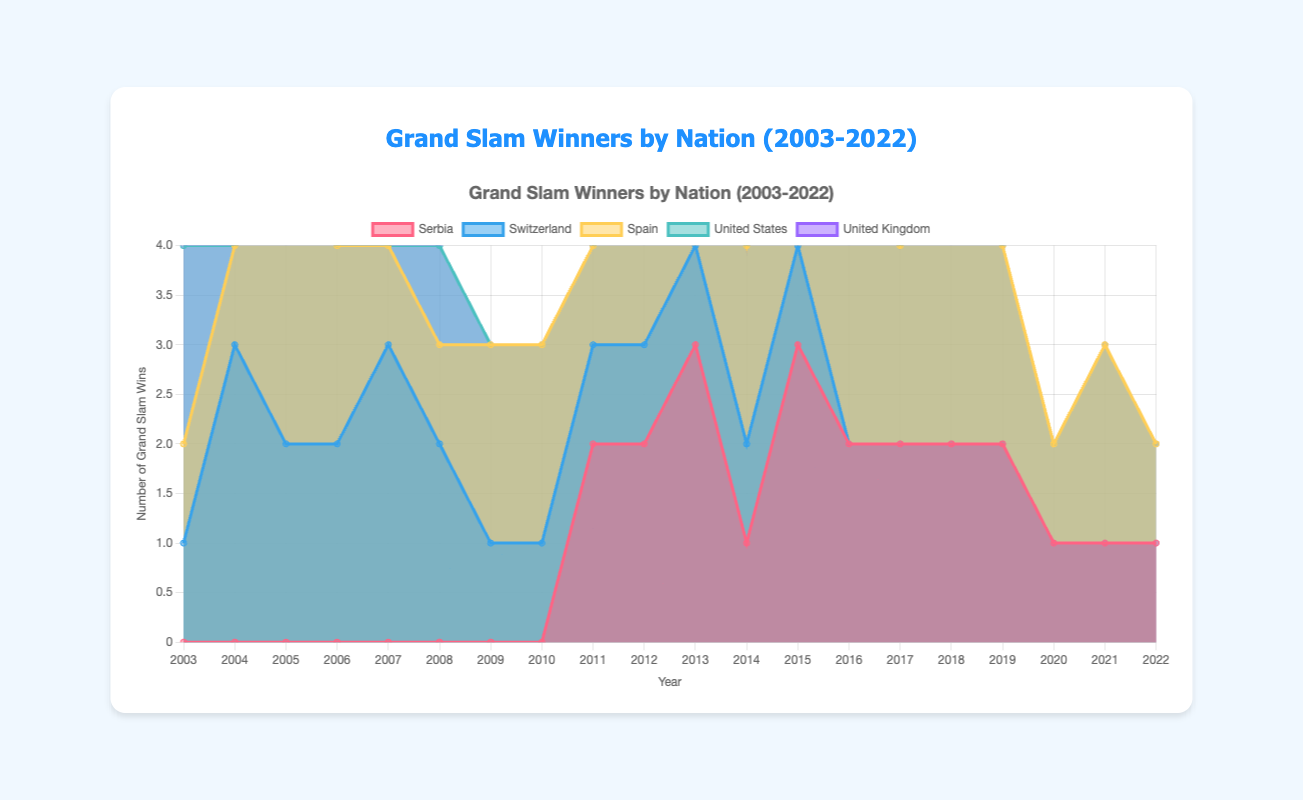How many Grand Slam wins did Serbia have in 2011? To find the number of Grand Slam wins for Serbia in 2011, look at the data point corresponding to 2011 under the 'Serbia' label.
Answer: 2 Which country had the highest number of Grand Slam wins in 2007? Compare the data points for all countries in the year 2007. Spain had 1 win, Serbia had 0, Switzerland had 3, United States had 0, and United Kingdom had 0.
Answer: Switzerland What is the total number of Grand Slam wins for Spain from 2003 to 2022? Add up all the data points for Spain: 1+1+3+2+1+1+2+2+1+3+2+2+3+3+2+3+2+1+2+1 = 38
Answer: 38 Which years did the United States win Grand Slam finals? Look at the data series for the United States and find non-zero years: 2003, 2005, 2008, and 2014.
Answer: 2003, 2005, 2008, 2014 Between 2008 and 2012, how many Grand Slam wins did Serbia accumulate? Sum the data points for Serbia from 2008 to 2012: 0+0+2+2+3 = 7
Answer: 7 Did the United Kingdom ever win more than one Grand Slam in any year? Check the data points for the United Kingdom. The highest value is 1, no year had more than 1 win.
Answer: No How did Serbia's performance change from 2010 to 2011? Compare the data points for Serbia in 2010 and 2011: Serbia had 0 wins in 2010 and 2 wins in 2011.
Answer: Increased Which country showed the most consistent performance over these years? Look for countries with fewer fluctuations in their data series. Spain and Switzerland have relatively stable patterns compared to others.
Answer: Spain or Switzerland What trend can be seen in Switzerland's performance from 2003 to 2022? Analyze the data series for Switzerland: A peak in the mid-2000s, with performance tapering to zero by 2015 onwards.
Answer: Declined In which year did Spain win the maximum number of Grand Slam finals? Identify the highest data point in the Spain series: 3 wins in 2005, 2010, 2013, 2014, 2015, and 2017.
Answer: Multiple years: 2005, 2010, 2013, 2014, 2015, 2017 